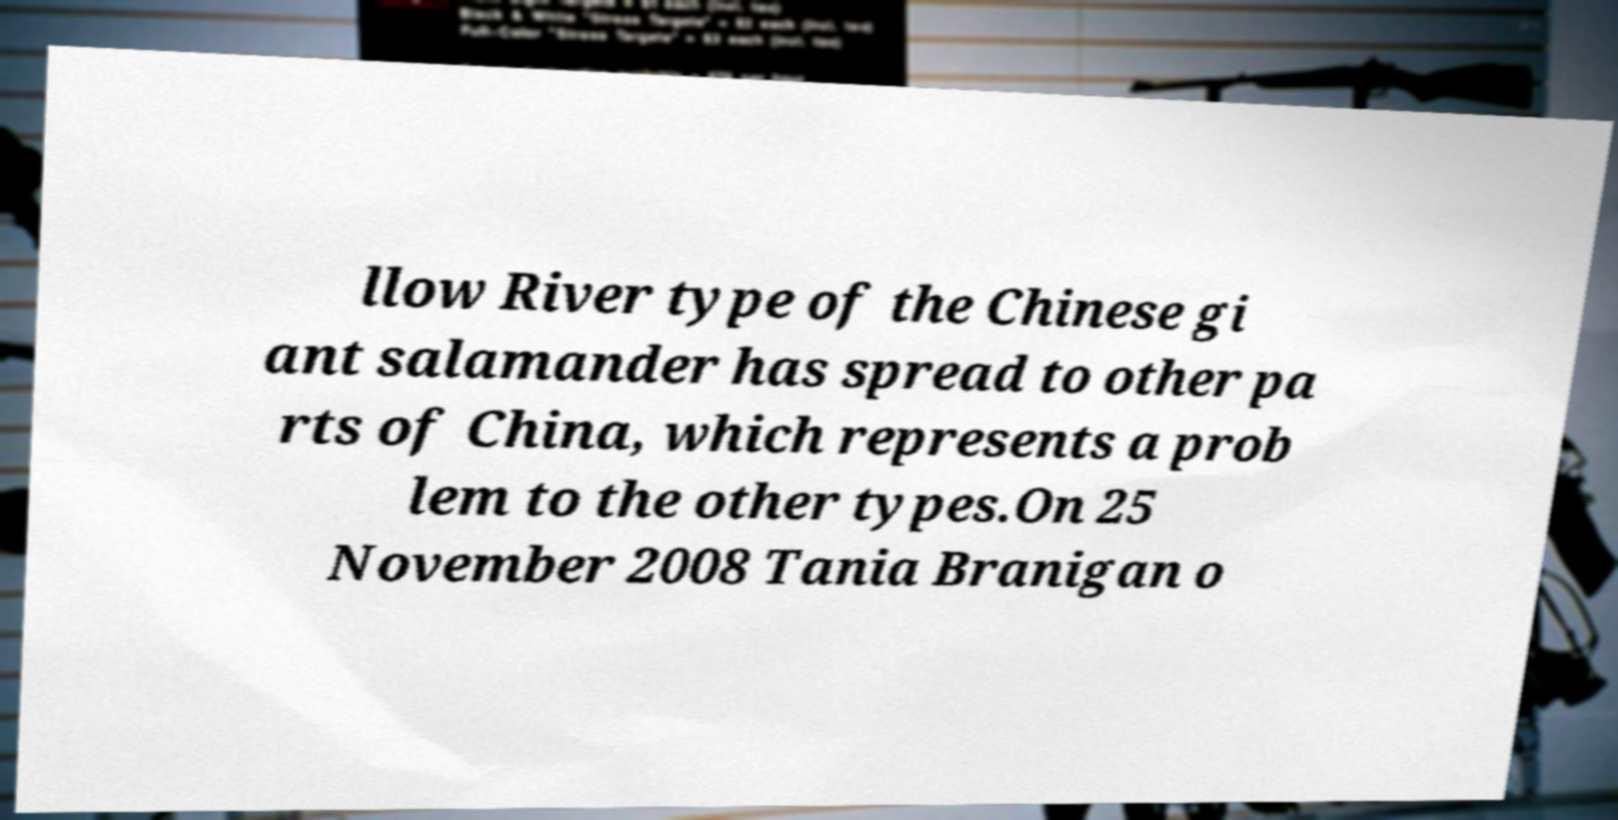What messages or text are displayed in this image? I need them in a readable, typed format. llow River type of the Chinese gi ant salamander has spread to other pa rts of China, which represents a prob lem to the other types.On 25 November 2008 Tania Branigan o 